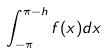Convert formula to latex. <formula><loc_0><loc_0><loc_500><loc_500>\int _ { - \pi } ^ { \pi - h } f ( x ) d x</formula> 